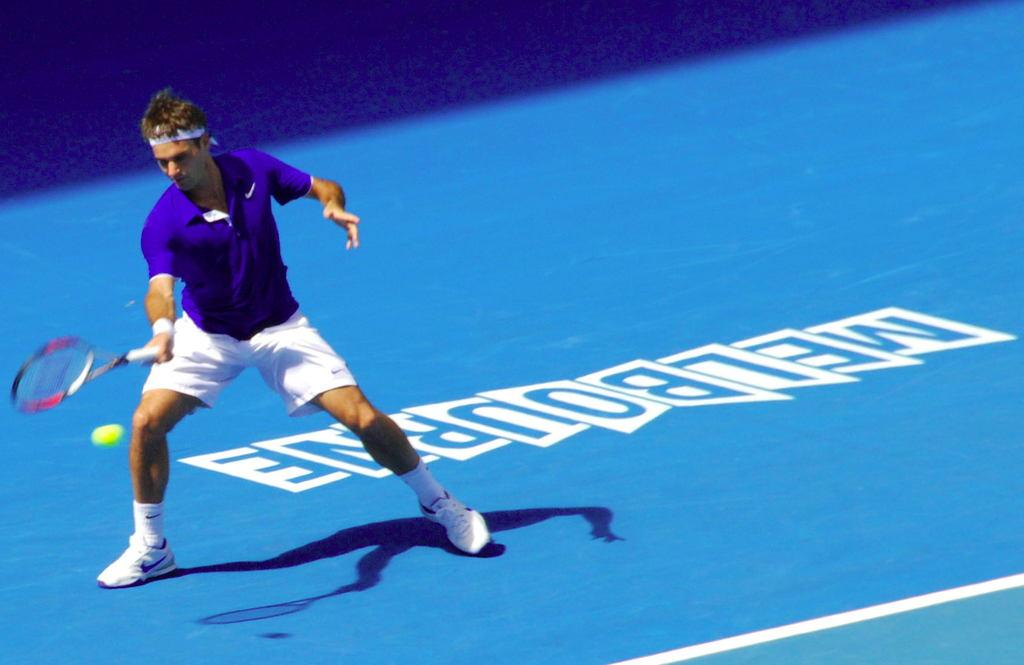What is the main subject of the image? The main subject of the image is a man standing. What is the man wearing on his feet? The man is wearing socks and shoes. What object is the man holding in his hand? The man is holding a tennis bat in his hand. What other object related to tennis can be seen in the image? There is a tennis ball in the image. What is the color of the surface the man is standing on? The surface is blue. What markings are visible on the blue surface? There are white lines on the blue surface. What type of day is depicted in the image? The provided facts do not mention any information about the day or time of day, so it cannot be determined from the image. Can you tell me what type of market is visible in the image? There is no market present in the image; it features a man holding a tennis bat and standing on a blue surface with white lines. 